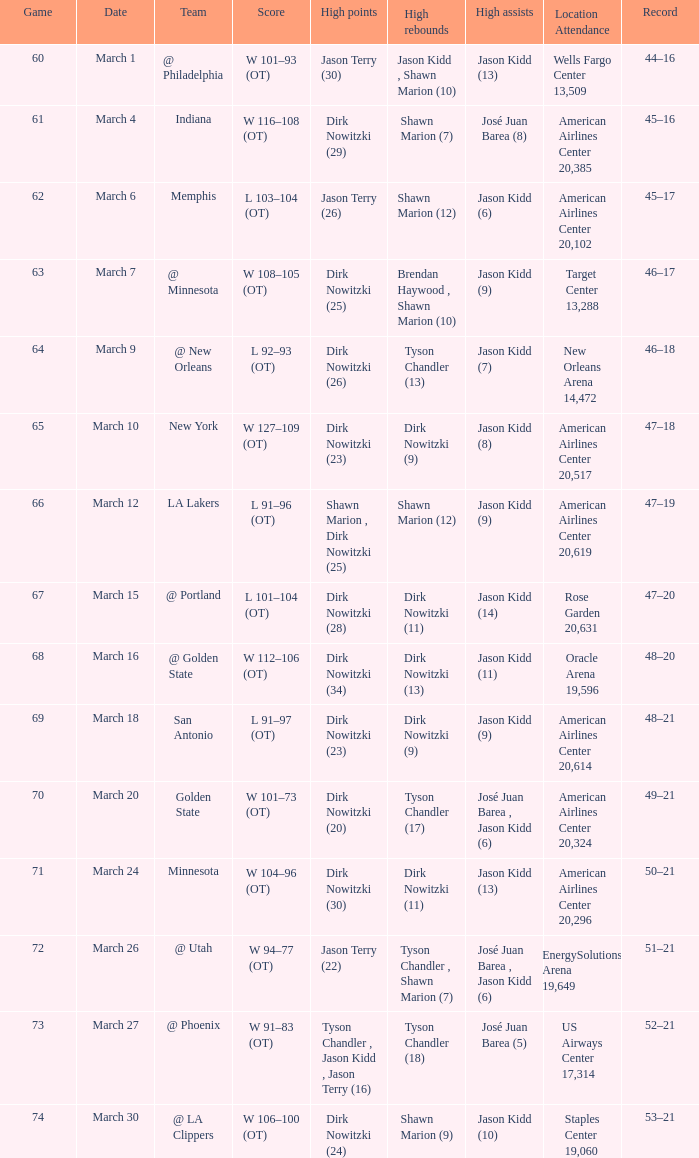Name the high assists for  l 103–104 (ot) Jason Kidd (6). 